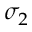Convert formula to latex. <formula><loc_0><loc_0><loc_500><loc_500>\sigma _ { 2 }</formula> 